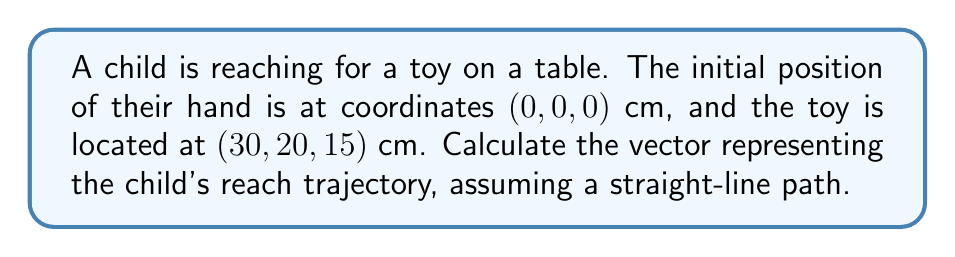Could you help me with this problem? To calculate the vector representing the child's reach trajectory, we need to follow these steps:

1. Identify the initial and final positions:
   Initial position: $\vec{i} = (0, 0, 0)$ cm
   Final position (toy location): $\vec{f} = (30, 20, 15)$ cm

2. Calculate the displacement vector by subtracting the initial position from the final position:
   $$\vec{v} = \vec{f} - \vec{i}$$
   $$\vec{v} = (30, 20, 15) - (0, 0, 0)$$
   $$\vec{v} = (30 - 0, 20 - 0, 15 - 0)$$
   $$\vec{v} = (30, 20, 15)$$

3. The resulting vector $\vec{v} = (30, 20, 15)$ represents the child's reach trajectory in centimeters.

This vector indicates that the child needs to reach:
- 30 cm in the x-direction
- 20 cm in the y-direction
- 15 cm in the z-direction

As an occupational therapist, you can use this information to assess the child's reaching capabilities and design appropriate interventions to improve their motor skills.
Answer: $\vec{v} = (30, 20, 15)$ cm 